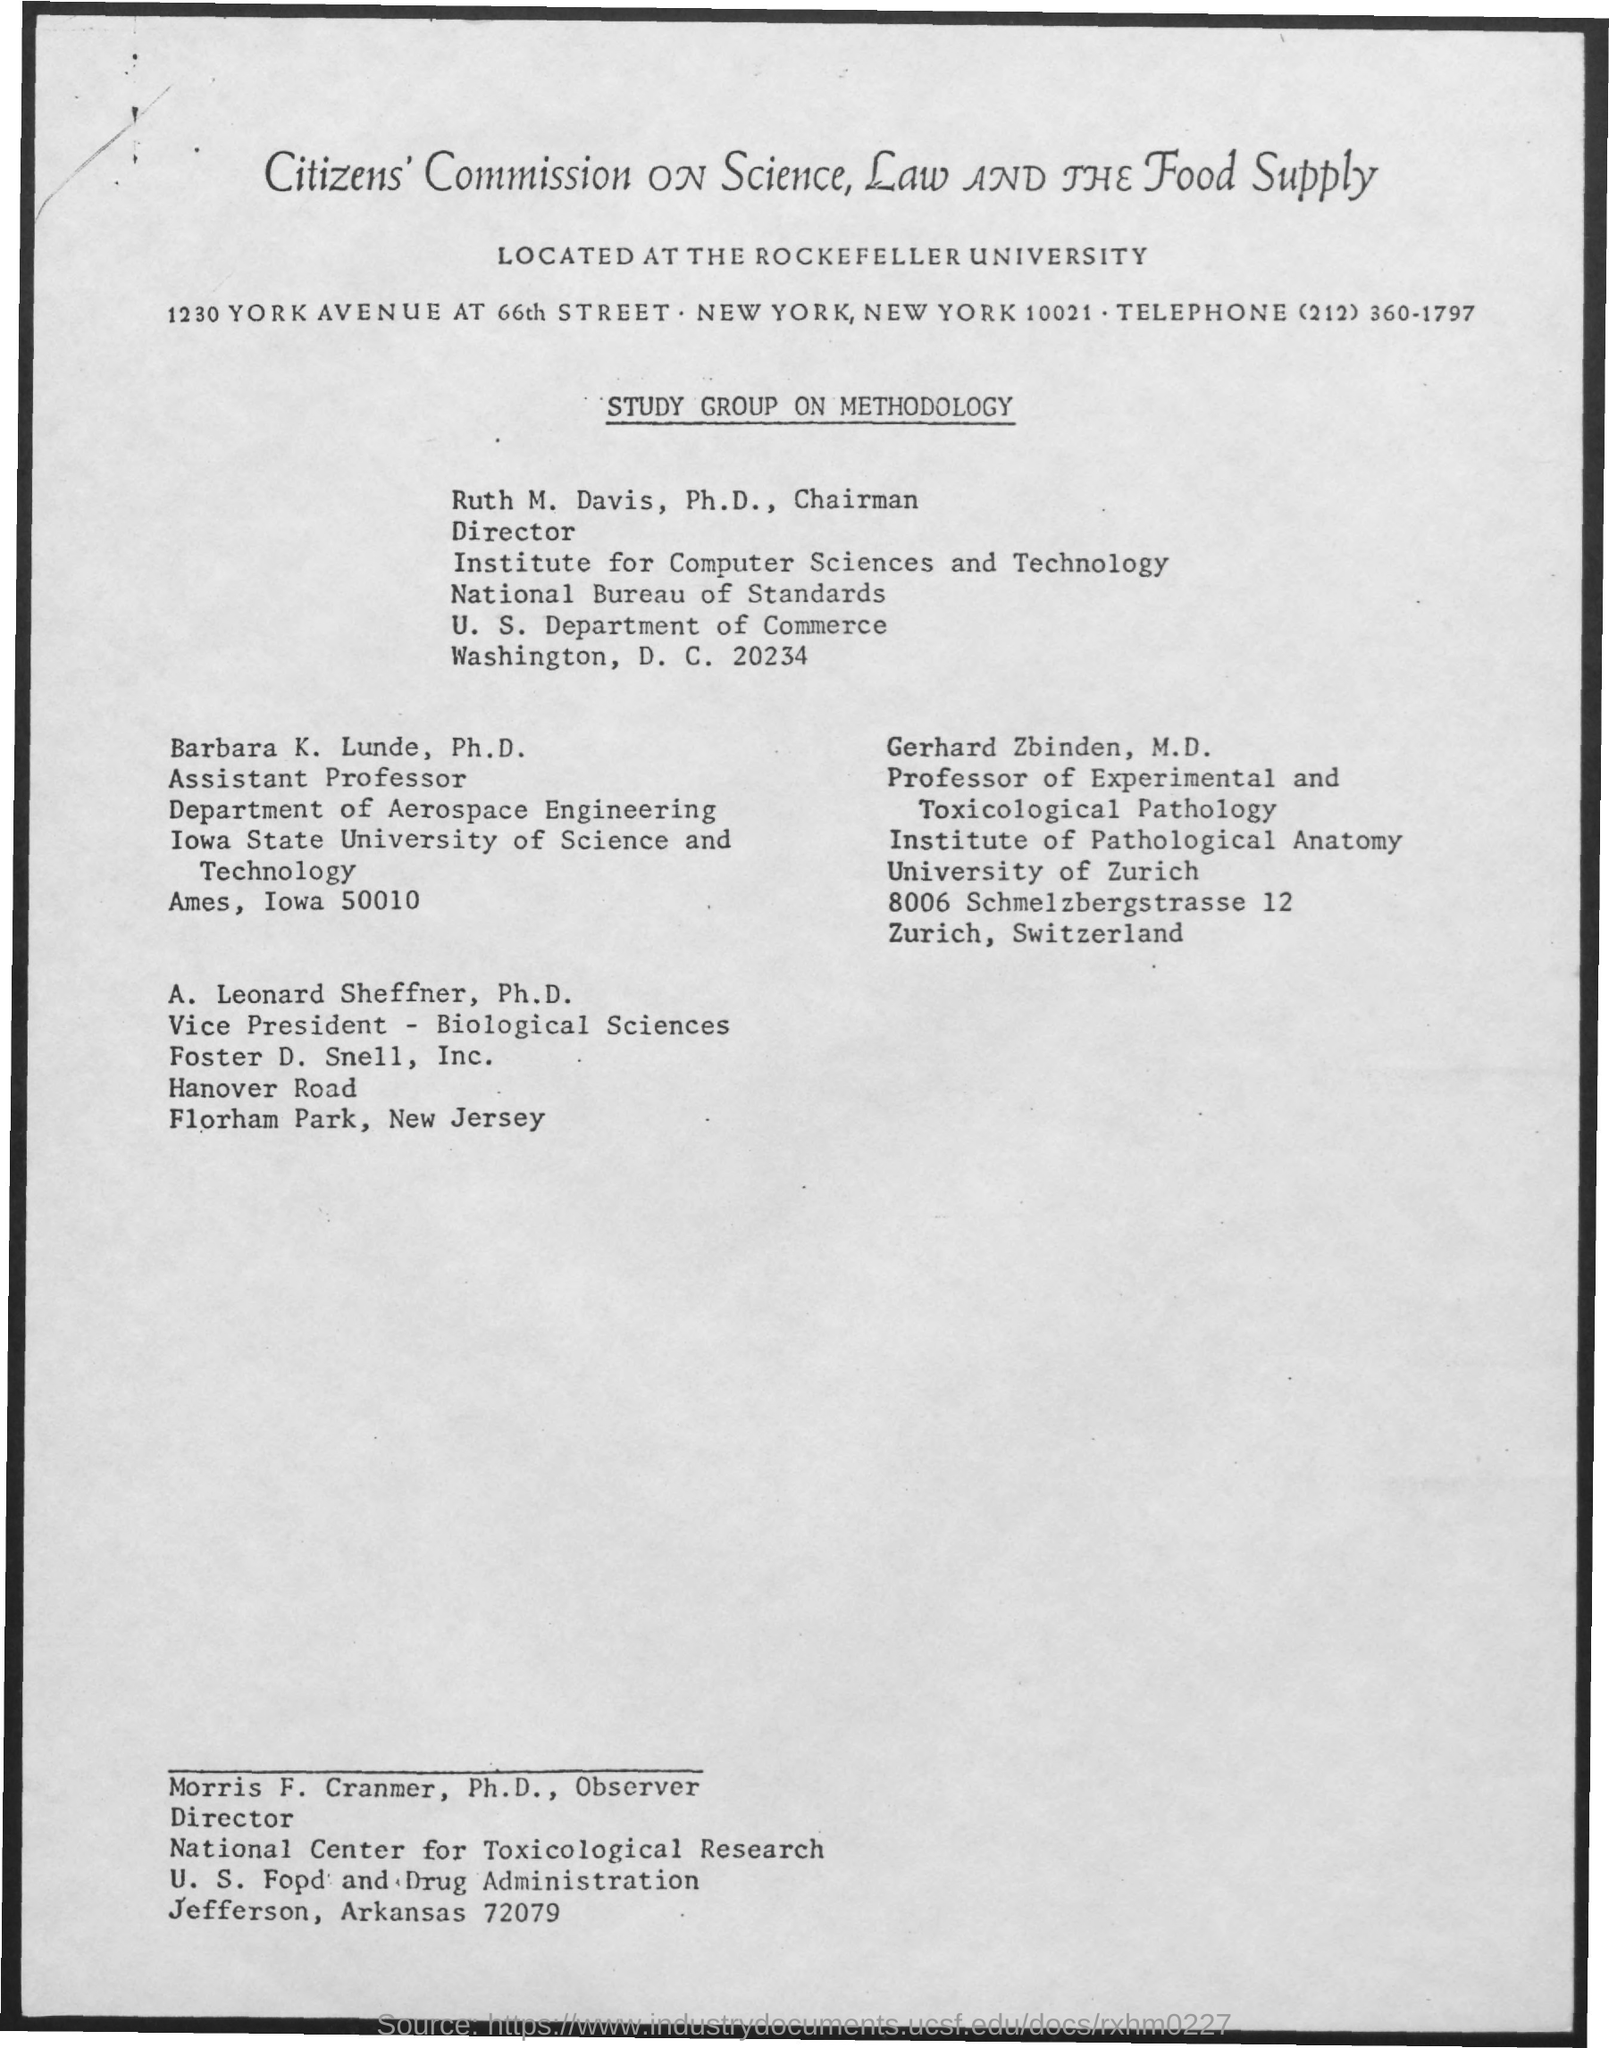Mention a couple of crucial points in this snapshot. Gerhard Zbinden, M.D. holds the designation of Professor of Experimental and Toxicological Pathology. Ruth M. Davis is the chairman of the Study Group on Methodology. 